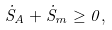Convert formula to latex. <formula><loc_0><loc_0><loc_500><loc_500>\dot { S } _ { A } + \dot { S } _ { m } \geq 0 ,</formula> 